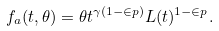Convert formula to latex. <formula><loc_0><loc_0><loc_500><loc_500>f _ { a } ( t , \theta ) = \theta t ^ { \gamma ( 1 - \in p ) } L ( t ) ^ { 1 - \in p } .</formula> 